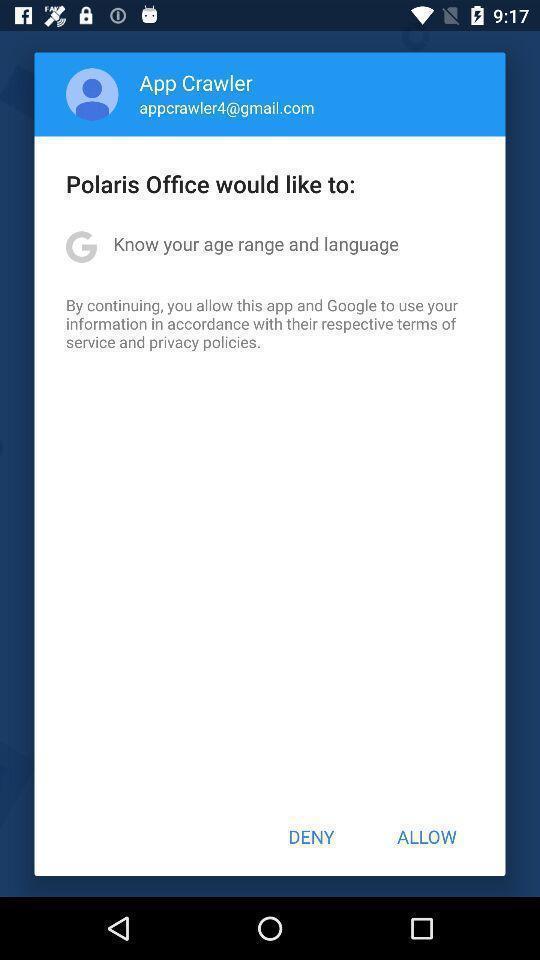Describe this image in words. Pop-up asking permissions to access the profile details. 